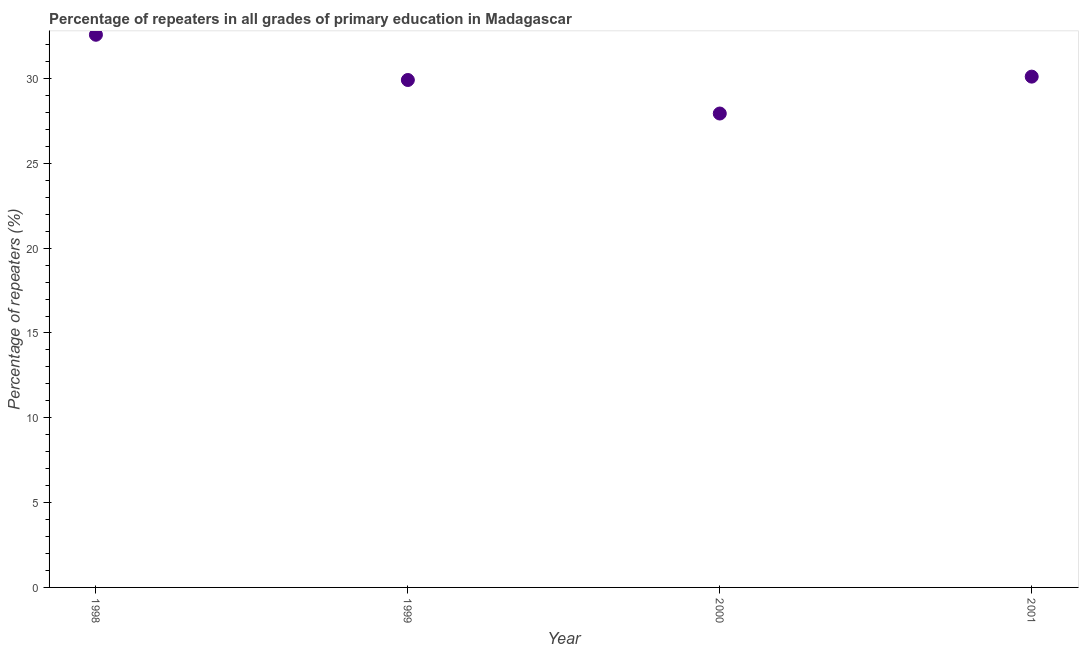What is the percentage of repeaters in primary education in 1998?
Provide a short and direct response. 32.58. Across all years, what is the maximum percentage of repeaters in primary education?
Keep it short and to the point. 32.58. Across all years, what is the minimum percentage of repeaters in primary education?
Give a very brief answer. 27.94. In which year was the percentage of repeaters in primary education minimum?
Your response must be concise. 2000. What is the sum of the percentage of repeaters in primary education?
Provide a succinct answer. 120.54. What is the difference between the percentage of repeaters in primary education in 1999 and 2001?
Give a very brief answer. -0.2. What is the average percentage of repeaters in primary education per year?
Your answer should be compact. 30.14. What is the median percentage of repeaters in primary education?
Offer a terse response. 30.01. In how many years, is the percentage of repeaters in primary education greater than 1 %?
Keep it short and to the point. 4. Do a majority of the years between 2000 and 1999 (inclusive) have percentage of repeaters in primary education greater than 20 %?
Your answer should be compact. No. What is the ratio of the percentage of repeaters in primary education in 1998 to that in 2001?
Ensure brevity in your answer.  1.08. What is the difference between the highest and the second highest percentage of repeaters in primary education?
Provide a short and direct response. 2.47. What is the difference between the highest and the lowest percentage of repeaters in primary education?
Ensure brevity in your answer.  4.64. In how many years, is the percentage of repeaters in primary education greater than the average percentage of repeaters in primary education taken over all years?
Provide a succinct answer. 1. How many dotlines are there?
Offer a very short reply. 1. How many years are there in the graph?
Offer a very short reply. 4. Does the graph contain any zero values?
Provide a succinct answer. No. Does the graph contain grids?
Offer a terse response. No. What is the title of the graph?
Your answer should be compact. Percentage of repeaters in all grades of primary education in Madagascar. What is the label or title of the X-axis?
Offer a terse response. Year. What is the label or title of the Y-axis?
Offer a terse response. Percentage of repeaters (%). What is the Percentage of repeaters (%) in 1998?
Make the answer very short. 32.58. What is the Percentage of repeaters (%) in 1999?
Provide a succinct answer. 29.91. What is the Percentage of repeaters (%) in 2000?
Provide a short and direct response. 27.94. What is the Percentage of repeaters (%) in 2001?
Your answer should be compact. 30.11. What is the difference between the Percentage of repeaters (%) in 1998 and 1999?
Provide a short and direct response. 2.67. What is the difference between the Percentage of repeaters (%) in 1998 and 2000?
Provide a succinct answer. 4.64. What is the difference between the Percentage of repeaters (%) in 1998 and 2001?
Offer a very short reply. 2.47. What is the difference between the Percentage of repeaters (%) in 1999 and 2000?
Offer a very short reply. 1.98. What is the difference between the Percentage of repeaters (%) in 1999 and 2001?
Ensure brevity in your answer.  -0.2. What is the difference between the Percentage of repeaters (%) in 2000 and 2001?
Offer a very short reply. -2.17. What is the ratio of the Percentage of repeaters (%) in 1998 to that in 1999?
Give a very brief answer. 1.09. What is the ratio of the Percentage of repeaters (%) in 1998 to that in 2000?
Offer a very short reply. 1.17. What is the ratio of the Percentage of repeaters (%) in 1998 to that in 2001?
Give a very brief answer. 1.08. What is the ratio of the Percentage of repeaters (%) in 1999 to that in 2000?
Your answer should be very brief. 1.07. What is the ratio of the Percentage of repeaters (%) in 1999 to that in 2001?
Your answer should be very brief. 0.99. What is the ratio of the Percentage of repeaters (%) in 2000 to that in 2001?
Give a very brief answer. 0.93. 